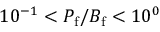Convert formula to latex. <formula><loc_0><loc_0><loc_500><loc_500>1 0 ^ { - 1 } < P _ { f } / B _ { f } < 1 0 ^ { 0 }</formula> 